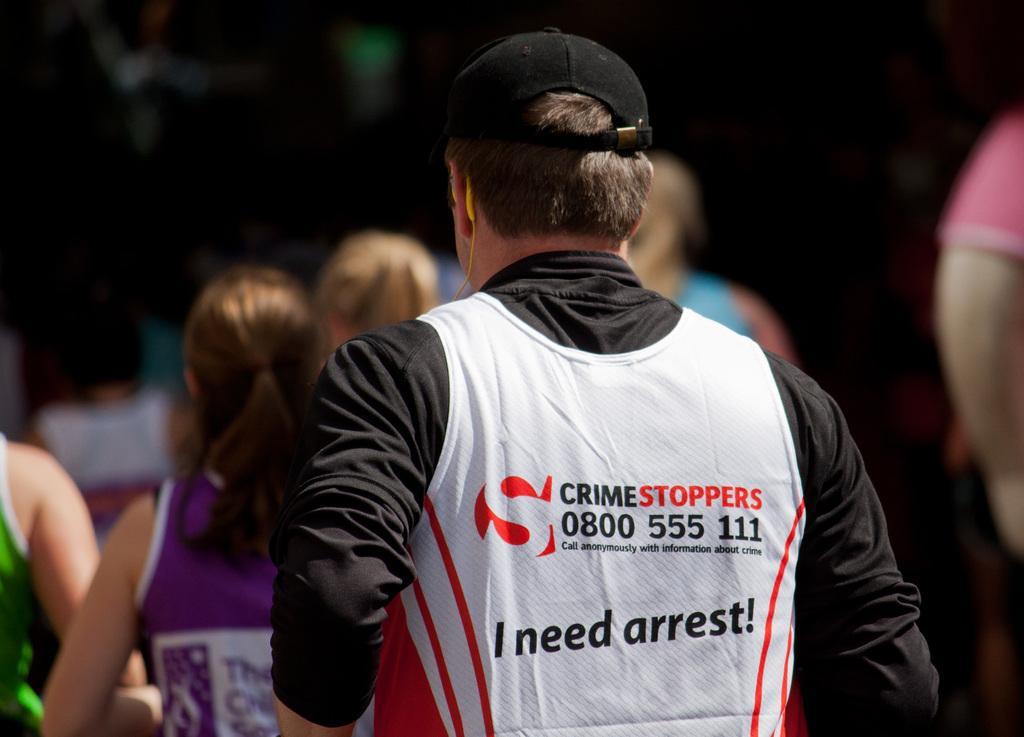Please provide a concise description of this image. This image consists of so many persons. In the front there is a person who is wearing a black shirt. He is wearing a cap. 